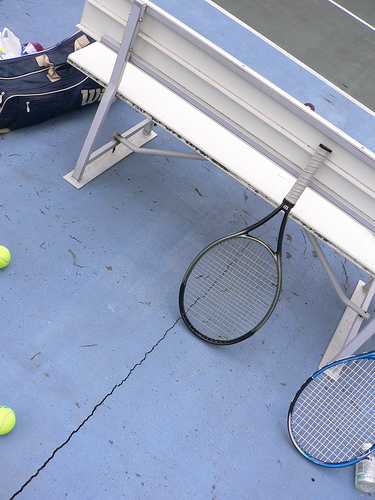Please transcribe the text information in this image. Wi 